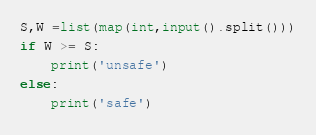<code> <loc_0><loc_0><loc_500><loc_500><_Python_>S,W =list(map(int,input().split()))
if W >= S:
    print('unsafe')
else:
    print('safe')</code> 